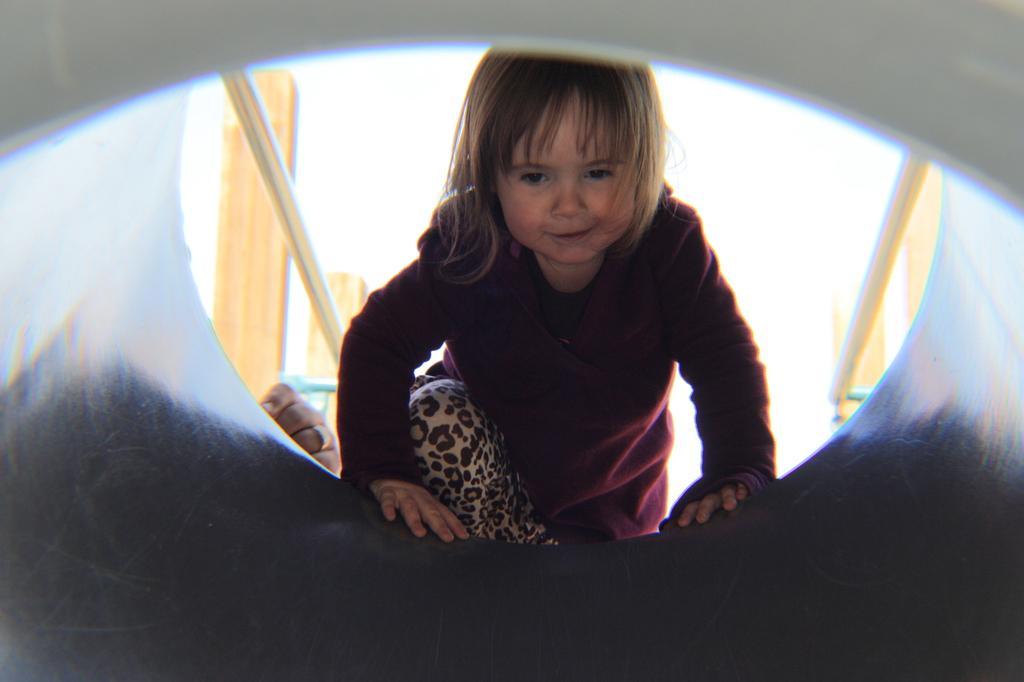Describe this image in one or two sentences. In this image we can see a kid entering into a tunnel like structure. In the background we can see a ring to person's finger, poles and other objects. 